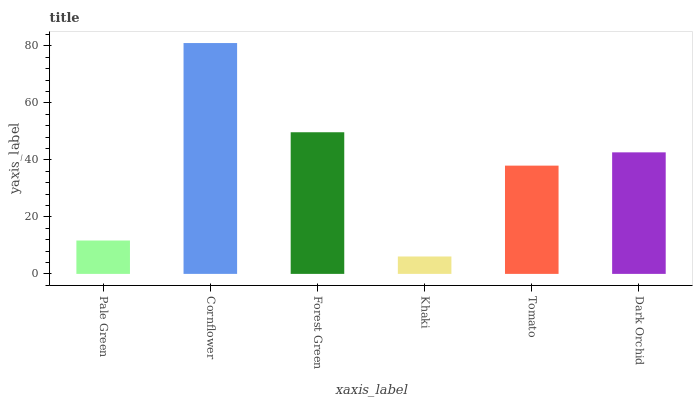Is Khaki the minimum?
Answer yes or no. Yes. Is Cornflower the maximum?
Answer yes or no. Yes. Is Forest Green the minimum?
Answer yes or no. No. Is Forest Green the maximum?
Answer yes or no. No. Is Cornflower greater than Forest Green?
Answer yes or no. Yes. Is Forest Green less than Cornflower?
Answer yes or no. Yes. Is Forest Green greater than Cornflower?
Answer yes or no. No. Is Cornflower less than Forest Green?
Answer yes or no. No. Is Dark Orchid the high median?
Answer yes or no. Yes. Is Tomato the low median?
Answer yes or no. Yes. Is Forest Green the high median?
Answer yes or no. No. Is Pale Green the low median?
Answer yes or no. No. 